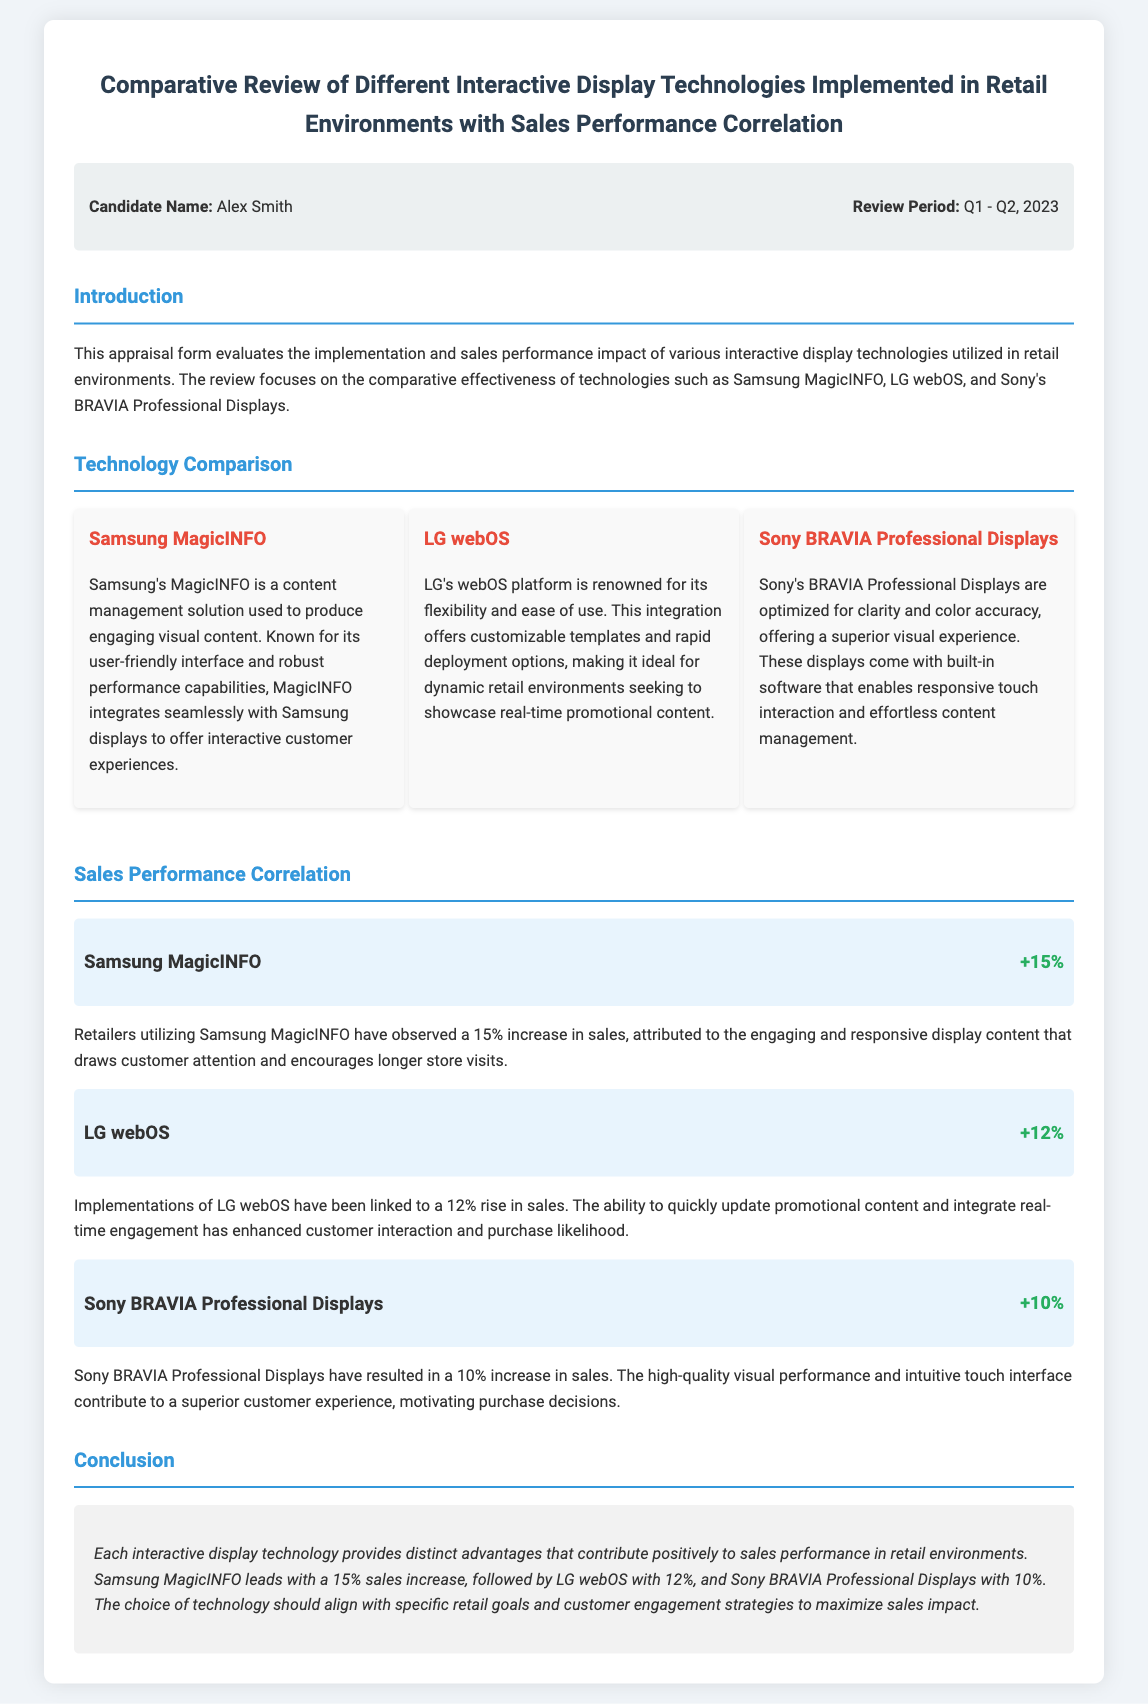what is the name of the candidate? The candidate name is provided in the document under the "info" section, which specifies "Alex Smith".
Answer: Alex Smith what is the review period? The review period is mentioned in the "info" section, stating "Q1 - Q2, 2023".
Answer: Q1 - Q2, 2023 which technology resulted in the highest sales increase? The sales performance correlation section indicates that "Samsung MagicINFO" led with a "15%" increase.
Answer: Samsung MagicINFO what increase in sales is attributed to LG webOS? The document states that LG webOS has been linked to a "12%" rise in sales.
Answer: 12% what is the primary benefit of using Sony BRAVIA Professional Displays? The document highlights that Sony BRAVIA Professional Displays offer a "superior visual experience".
Answer: superior visual experience how much sales increase does Samsung MagicINFO provide? As stated in the sales impact section, "Samsung MagicINFO" provides a "+15%" increase.
Answer: +15% what is the conclusion regarding interactive display technologies? The conclusion summarizes that each technology provides distinct advantages contributing positively to sales performance.
Answer: distinct advantages which display technology is described as having a user-friendly interface? The document mentions "Samsung's MagicINFO" for its user-friendly interface.
Answer: Samsung's MagicINFO 